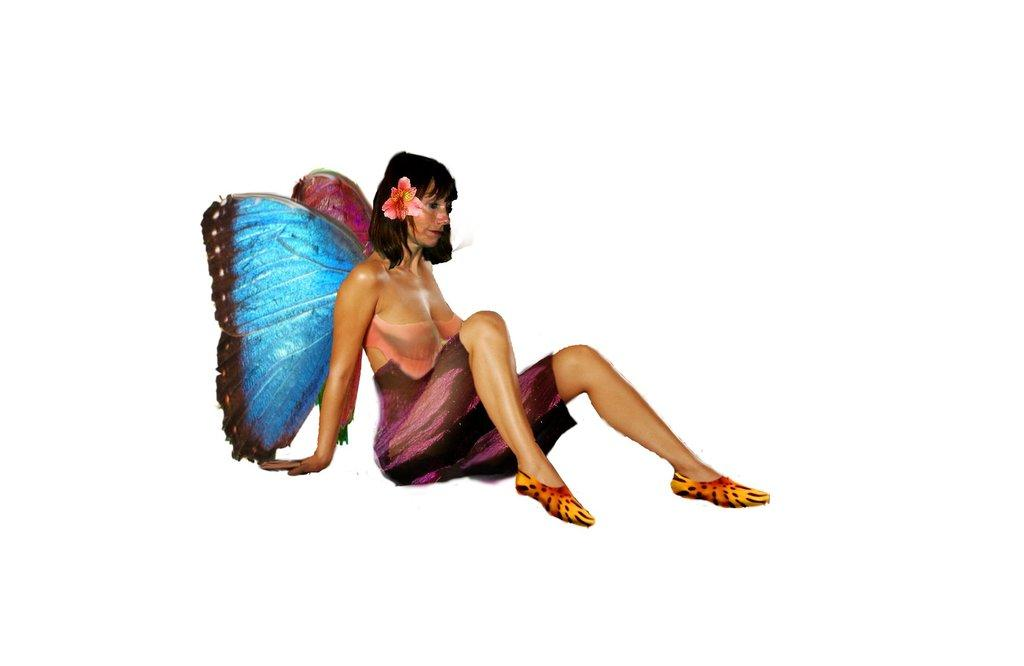Who is the main subject in the image? There is a woman in the image. What distinguishing feature does the woman have? The woman has butterfly wings. What accessory is the woman wearing in her hair? The woman has a flower in her hair. How many sheep are visible in the image? There are no sheep present in the image. What is the mass of the person in the image? The image does not provide information about the mass of the person. 